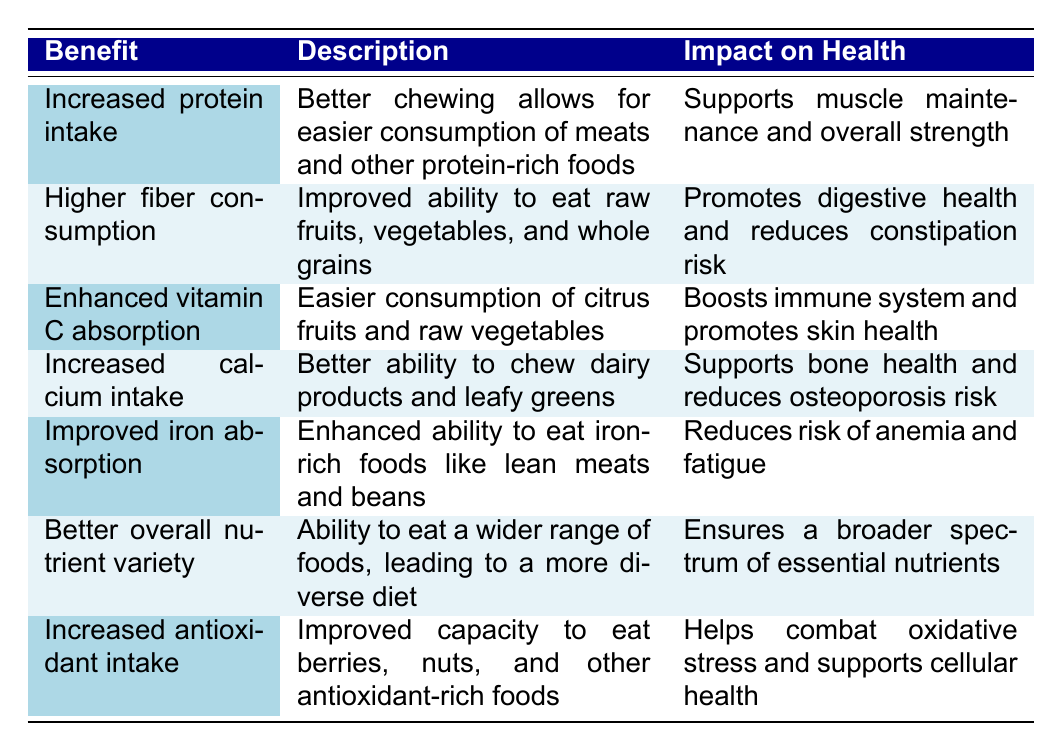What are the benefits associated with improved chewing ability? The table lists several benefits, including increased protein intake, higher fiber consumption, enhanced vitamin C absorption, increased calcium intake, improved iron absorption, better overall nutrient variety, and increased antioxidant intake.
Answer: Increased protein intake, higher fiber consumption, enhanced vitamin C absorption, increased calcium intake, improved iron absorption, better overall nutrient variety, increased antioxidant intake Which benefit focuses on digestive health? The benefit that focuses on digestive health is higher fiber consumption, which allows easier consumption of raw fruits, vegetables, and whole grains.
Answer: Higher fiber consumption Does improved chewing ability help in reducing the risk of anemia? Yes, improved chewing ability enhances the ability to eat iron-rich foods, which reduces the risk of anemia.
Answer: Yes Which nutrient helps support bone health? Increased calcium intake supports bone health and reduces the risk of osteoporosis.
Answer: Calcium What is required for better absorption of vitamin C according to the table? Easier consumption of citrus fruits and raw vegetables is required for better absorption of vitamin C.
Answer: Easier consumption of citrus fruits and raw vegetables How many benefits mentioned relate to overall health support? Six benefits relate to overall health support: increased protein intake, higher fiber consumption, enhanced vitamin C absorption, increased calcium intake, improved iron absorption, and increased antioxidant intake.
Answer: Six If an elderly person improves their ability to chew, what types of foods will they find easier to consume? They will find it easier to consume meats, raw fruits, vegetables, whole grains, dairy products, leafy greens, iron-rich foods, berries, and nuts.
Answer: Meats, raw fruits, vegetables, whole grains, dairy products, leafy greens, iron-rich foods, berries, nuts Which benefit leads to a diverse diet? Better overall nutrient variety leads to a more diverse diet by allowing the consumption of a wider range of foods.
Answer: Better overall nutrient variety Are fruits and vegetables essential for enhancing the ability to absorb any vitamins? Yes, fruits and vegetables are essential for enhancing the ability to absorb vitamin C as indicated in the table.
Answer: Yes What is the overall impact of increased antioxidant intake? Increased antioxidant intake helps combat oxidative stress and supports cellular health.
Answer: Combat oxidative stress and supports cellular health 